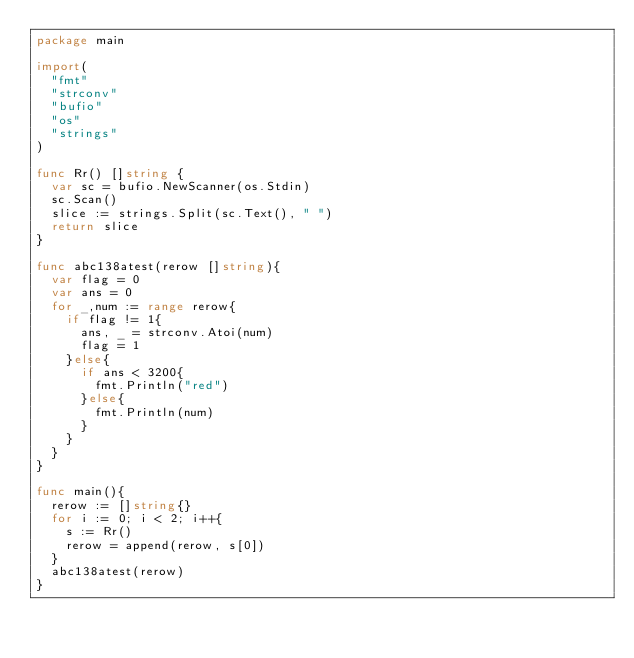Convert code to text. <code><loc_0><loc_0><loc_500><loc_500><_Go_>package main

import(
  "fmt"
  "strconv"
	"bufio"
	"os"
	"strings"
)

func Rr() []string {
	var sc = bufio.NewScanner(os.Stdin)
  sc.Scan()
  slice := strings.Split(sc.Text(), " ")
  return slice
}

func abc138atest(rerow []string){
	var flag = 0
	var ans = 0
	for _,num := range rerow{
		if flag != 1{
			ans, _ = strconv.Atoi(num)
			flag = 1
		}else{
			if ans < 3200{
				fmt.Println("red")
			}else{
				fmt.Println(num)
			}
		}
	}
}

func main(){
	rerow := []string{}
	for i := 0; i < 2; i++{
		s := Rr()
		rerow = append(rerow, s[0])
	}
	abc138atest(rerow)
}</code> 